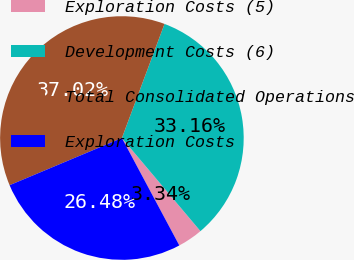Convert chart to OTSL. <chart><loc_0><loc_0><loc_500><loc_500><pie_chart><fcel>Exploration Costs (5)<fcel>Development Costs (6)<fcel>Total Consolidated Operations<fcel>Exploration Costs<nl><fcel>3.34%<fcel>33.16%<fcel>37.02%<fcel>26.48%<nl></chart> 